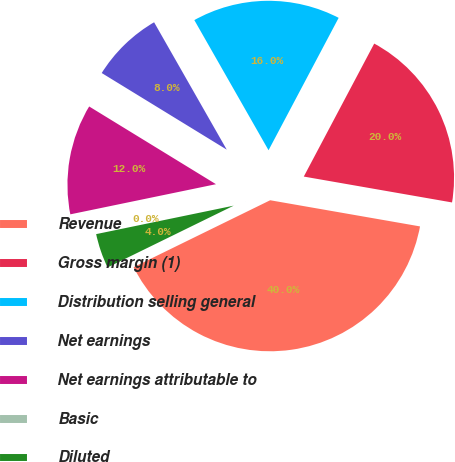Convert chart. <chart><loc_0><loc_0><loc_500><loc_500><pie_chart><fcel>Revenue<fcel>Gross margin (1)<fcel>Distribution selling general<fcel>Net earnings<fcel>Net earnings attributable to<fcel>Basic<fcel>Diluted<nl><fcel>40.0%<fcel>20.0%<fcel>16.0%<fcel>8.0%<fcel>12.0%<fcel>0.0%<fcel>4.0%<nl></chart> 